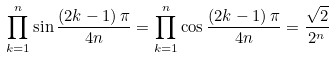<formula> <loc_0><loc_0><loc_500><loc_500>\prod _ { k = 1 } ^ { n } \sin { \frac { \left ( 2 k - 1 \right ) \pi } { 4 n } } = \prod _ { k = 1 } ^ { n } \cos { \frac { \left ( 2 k - 1 \right ) \pi } { 4 n } } = { \frac { \sqrt { 2 } } { 2 ^ { n } } }</formula> 